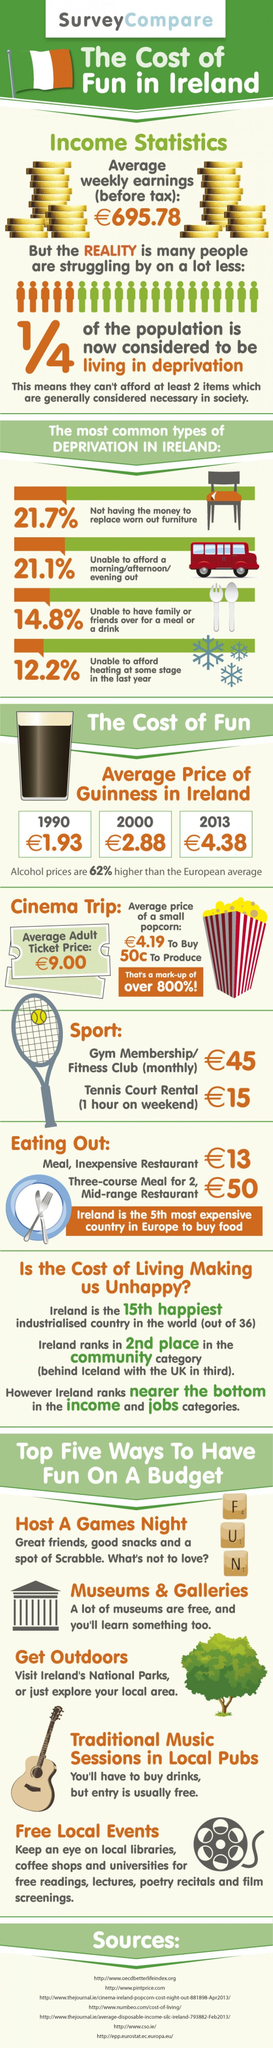Give some essential details in this illustration. In the year 1990, a Guinness was priced at 1.93. Scrabble has been mentioned as a fun board game that can be enjoyed by many. Museums and galleries are an affordable way to have fun, as listed second. 